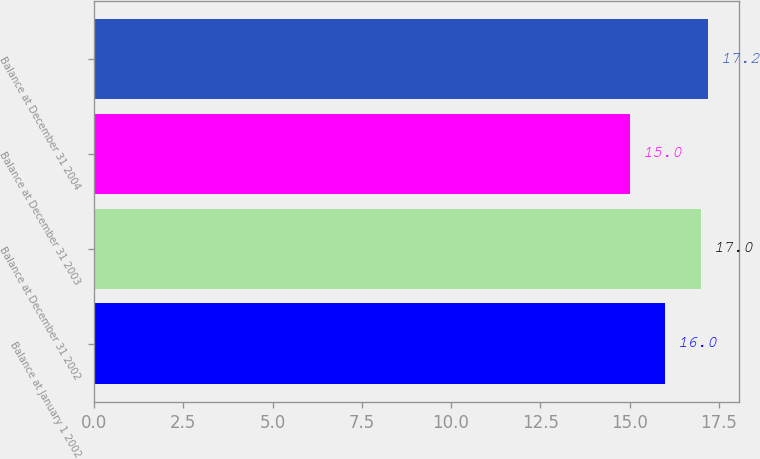Convert chart. <chart><loc_0><loc_0><loc_500><loc_500><bar_chart><fcel>Balance at January 1 2002<fcel>Balance at December 31 2002<fcel>Balance at December 31 2003<fcel>Balance at December 31 2004<nl><fcel>16<fcel>17<fcel>15<fcel>17.2<nl></chart> 